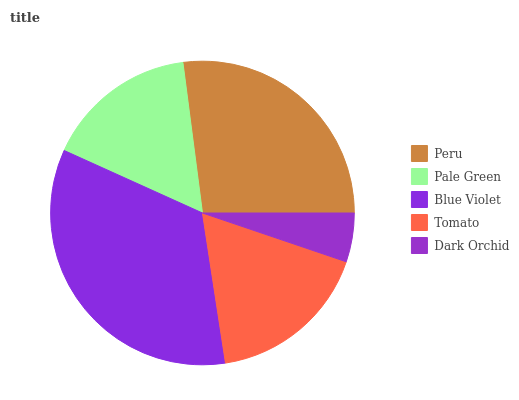Is Dark Orchid the minimum?
Answer yes or no. Yes. Is Blue Violet the maximum?
Answer yes or no. Yes. Is Pale Green the minimum?
Answer yes or no. No. Is Pale Green the maximum?
Answer yes or no. No. Is Peru greater than Pale Green?
Answer yes or no. Yes. Is Pale Green less than Peru?
Answer yes or no. Yes. Is Pale Green greater than Peru?
Answer yes or no. No. Is Peru less than Pale Green?
Answer yes or no. No. Is Tomato the high median?
Answer yes or no. Yes. Is Tomato the low median?
Answer yes or no. Yes. Is Peru the high median?
Answer yes or no. No. Is Dark Orchid the low median?
Answer yes or no. No. 